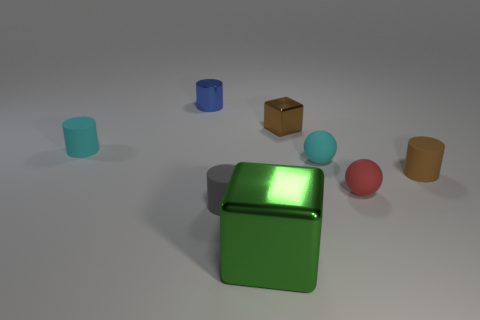Add 1 small green metallic objects. How many objects exist? 9 Subtract all tiny metal cylinders. How many cylinders are left? 3 Subtract all brown cylinders. How many cylinders are left? 3 Subtract 2 cylinders. How many cylinders are left? 2 Subtract all blocks. How many objects are left? 6 Subtract all gray cylinders. Subtract all blue balls. How many cylinders are left? 3 Add 1 large yellow rubber blocks. How many large yellow rubber blocks exist? 1 Subtract 0 purple cubes. How many objects are left? 8 Subtract all metal cubes. Subtract all small cyan objects. How many objects are left? 4 Add 3 blue cylinders. How many blue cylinders are left? 4 